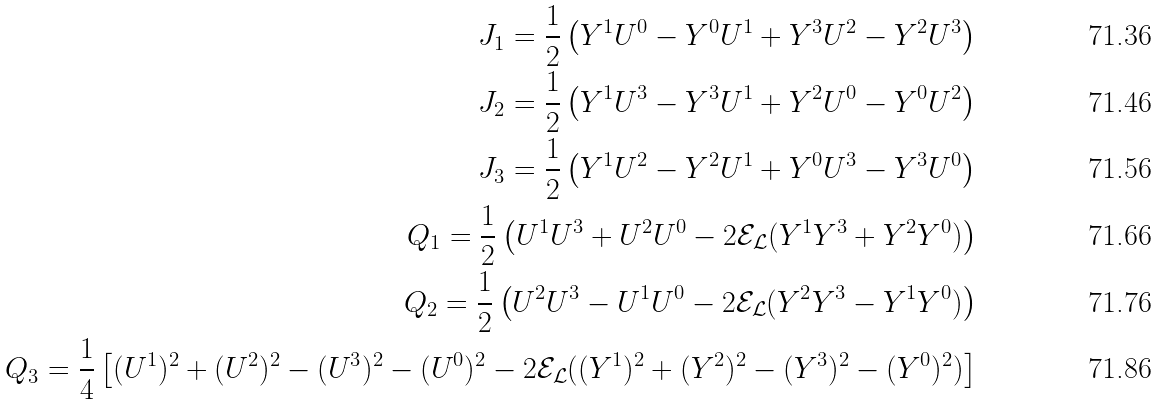<formula> <loc_0><loc_0><loc_500><loc_500>J _ { 1 } = \frac { 1 } { 2 } \left ( Y ^ { 1 } U ^ { 0 } - Y ^ { 0 } U ^ { 1 } + Y ^ { 3 } U ^ { 2 } - Y ^ { 2 } U ^ { 3 } \right ) \\ J _ { 2 } = \frac { 1 } { 2 } \left ( Y ^ { 1 } U ^ { 3 } - Y ^ { 3 } U ^ { 1 } + Y ^ { 2 } U ^ { 0 } - Y ^ { 0 } U ^ { 2 } \right ) \\ J _ { 3 } = \frac { 1 } { 2 } \left ( Y ^ { 1 } U ^ { 2 } - Y ^ { 2 } U ^ { 1 } + Y ^ { 0 } U ^ { 3 } - Y ^ { 3 } U ^ { 0 } \right ) \\ Q _ { 1 } = \frac { 1 } { 2 } \left ( U ^ { 1 } U ^ { 3 } + U ^ { 2 } U ^ { 0 } - 2 \mathcal { E } _ { \mathcal { L } } ( Y ^ { 1 } Y ^ { 3 } + Y ^ { 2 } Y ^ { 0 } ) \right ) \\ Q _ { 2 } = \frac { 1 } { 2 } \left ( U ^ { 2 } U ^ { 3 } - U ^ { 1 } U ^ { 0 } - 2 \mathcal { E } _ { \mathcal { L } } ( Y ^ { 2 } Y ^ { 3 } - Y ^ { 1 } Y ^ { 0 } ) \right ) \\ Q _ { 3 } = \frac { 1 } { 4 } \left [ ( U ^ { 1 } ) ^ { 2 } + ( U ^ { 2 } ) ^ { 2 } - ( U ^ { 3 } ) ^ { 2 } - ( U ^ { 0 } ) ^ { 2 } - 2 \mathcal { E } _ { \mathcal { L } } ( ( Y ^ { 1 } ) ^ { 2 } + ( Y ^ { 2 } ) ^ { 2 } - ( Y ^ { 3 } ) ^ { 2 } - ( Y ^ { 0 } ) ^ { 2 } ) \right ]</formula> 